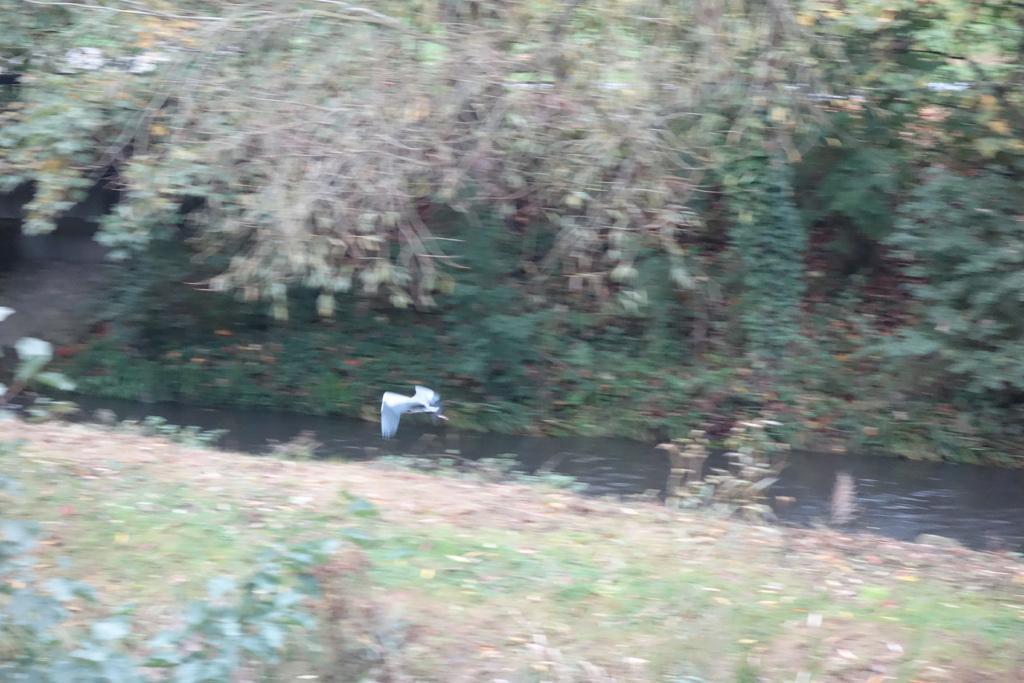Could you give a brief overview of what you see in this image? Blur image. Bird is flying in the air. Here we can see plants, trees and water. 